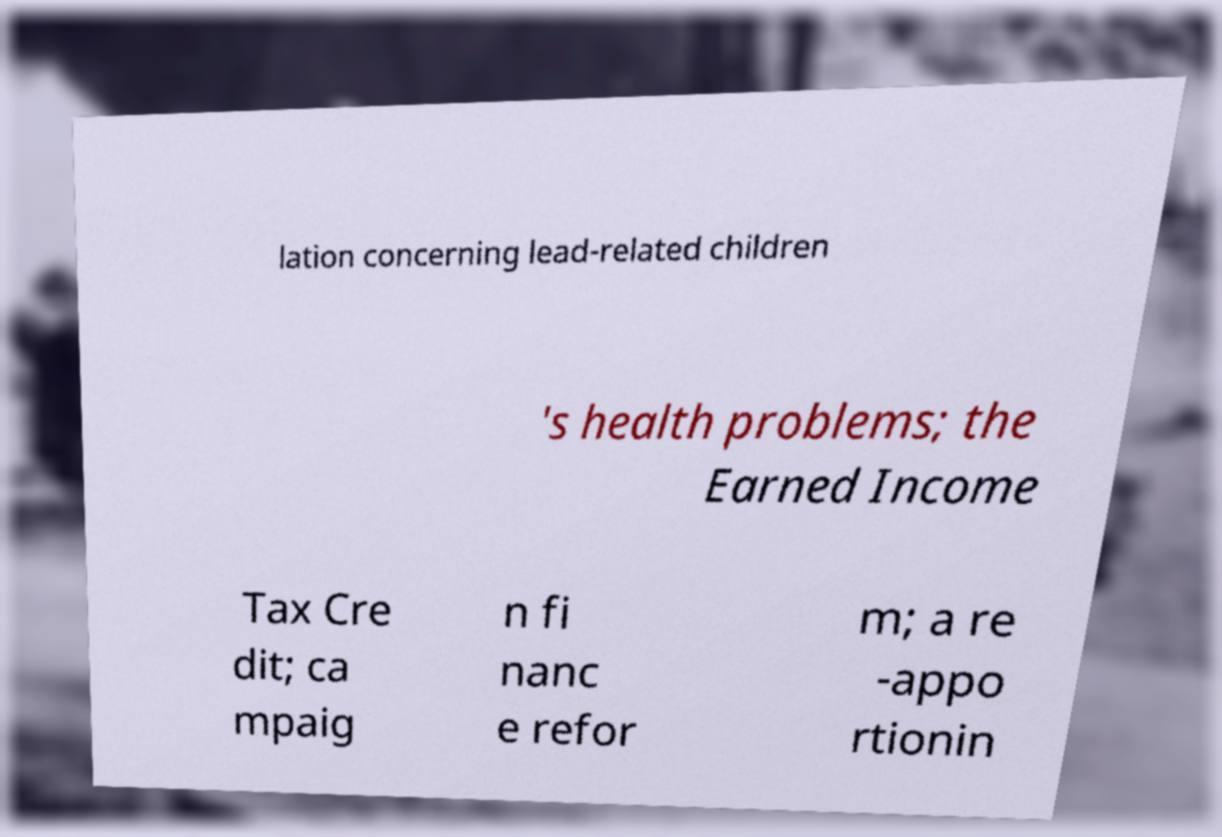What messages or text are displayed in this image? I need them in a readable, typed format. lation concerning lead-related children 's health problems; the Earned Income Tax Cre dit; ca mpaig n fi nanc e refor m; a re -appo rtionin 